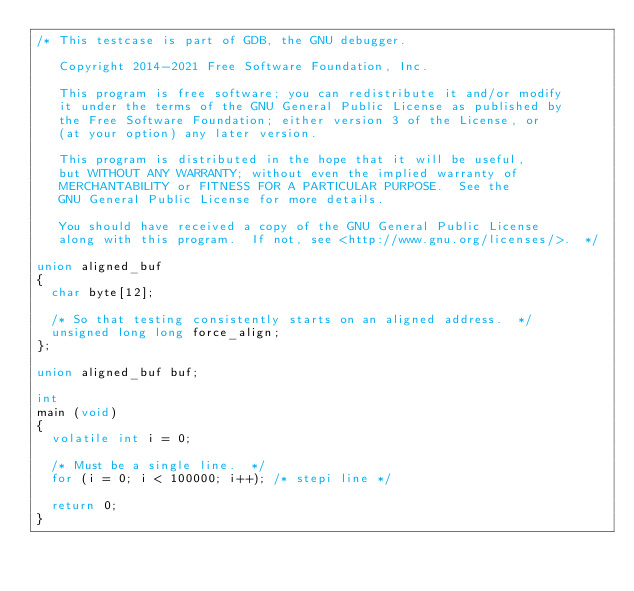<code> <loc_0><loc_0><loc_500><loc_500><_C_>/* This testcase is part of GDB, the GNU debugger.

   Copyright 2014-2021 Free Software Foundation, Inc.

   This program is free software; you can redistribute it and/or modify
   it under the terms of the GNU General Public License as published by
   the Free Software Foundation; either version 3 of the License, or
   (at your option) any later version.

   This program is distributed in the hope that it will be useful,
   but WITHOUT ANY WARRANTY; without even the implied warranty of
   MERCHANTABILITY or FITNESS FOR A PARTICULAR PURPOSE.  See the
   GNU General Public License for more details.

   You should have received a copy of the GNU General Public License
   along with this program.  If not, see <http://www.gnu.org/licenses/>.  */

union aligned_buf
{
  char byte[12];

  /* So that testing consistently starts on an aligned address.  */
  unsigned long long force_align;
};

union aligned_buf buf;

int
main (void)
{
  volatile int i = 0;

  /* Must be a single line.  */
  for (i = 0; i < 100000; i++); /* stepi line */

  return 0;
}
</code> 